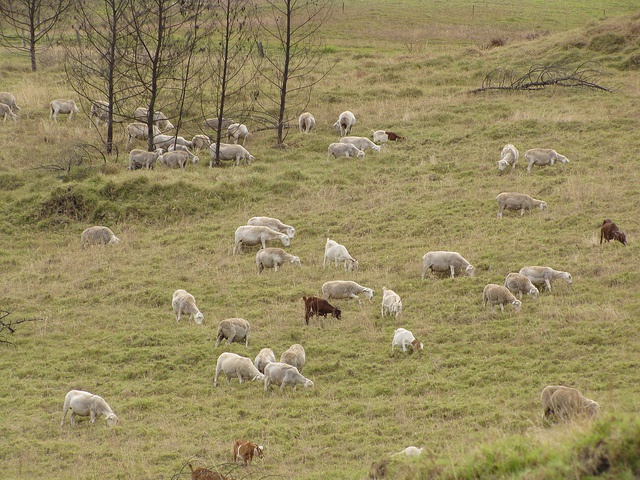Describe the objects in this image and their specific colors. I can see sheep in gray, tan, and darkgray tones, sheep in gray, darkgray, and lightgray tones, sheep in gray and darkgray tones, sheep in gray and darkgray tones, and sheep in gray, darkgray, tan, and lightgray tones in this image. 